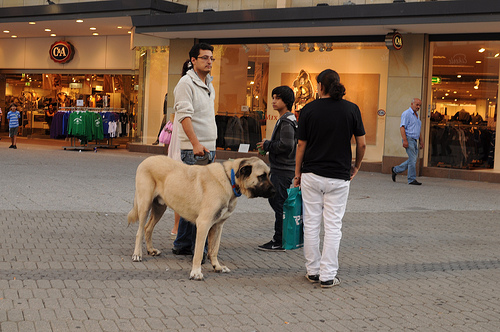Who is older, the woman or the child? The woman is older than the child, exhibiting more mature features and a composed demeanor. 